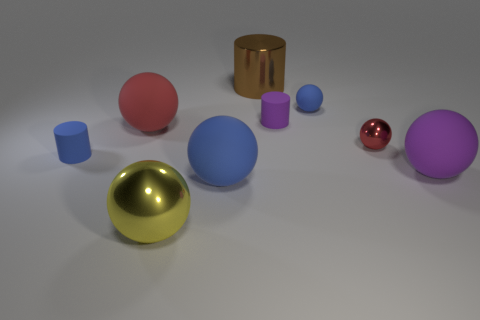Is there a tiny rubber object that has the same color as the tiny metal sphere? Upon reviewing the image, it appears there is no tiny rubber object matching the color of any of the metal spheres present. The objects vary in color and material, but none of the rubber objects share their hue with the metal spheres. 